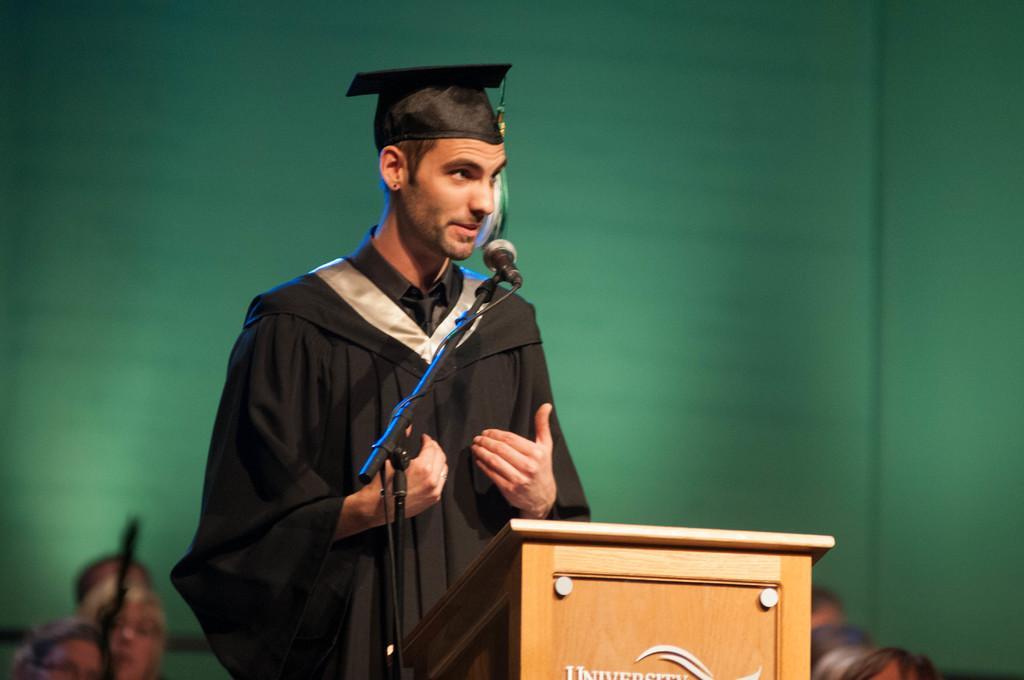Describe this image in one or two sentences. In this picture there is a boy in the center of the image and there is a mic and a desk in front of him and there are people at the bottom side of the image, it seems to be he is on the stage. 